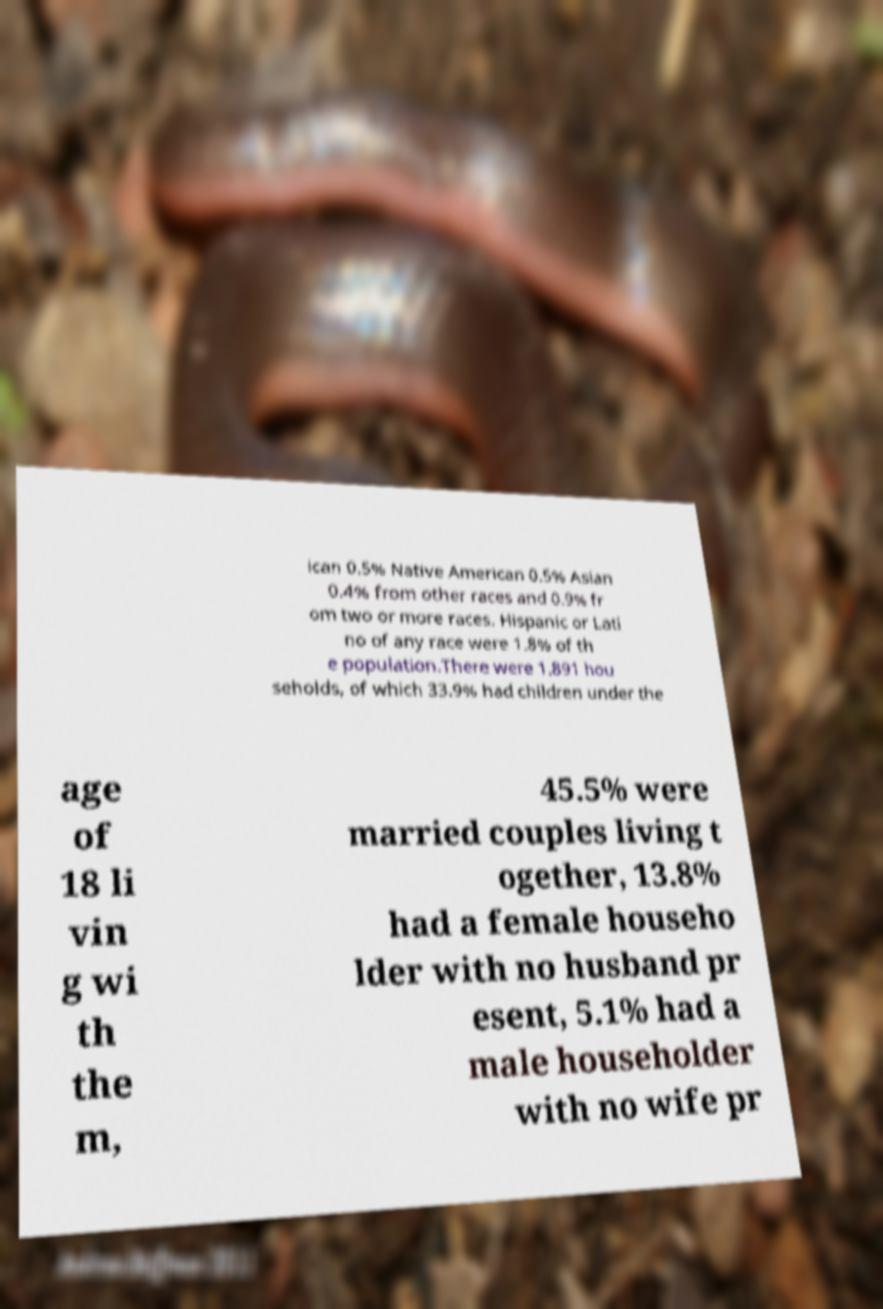Can you read and provide the text displayed in the image?This photo seems to have some interesting text. Can you extract and type it out for me? ican 0.5% Native American 0.5% Asian 0.4% from other races and 0.9% fr om two or more races. Hispanic or Lati no of any race were 1.8% of th e population.There were 1,891 hou seholds, of which 33.9% had children under the age of 18 li vin g wi th the m, 45.5% were married couples living t ogether, 13.8% had a female househo lder with no husband pr esent, 5.1% had a male householder with no wife pr 